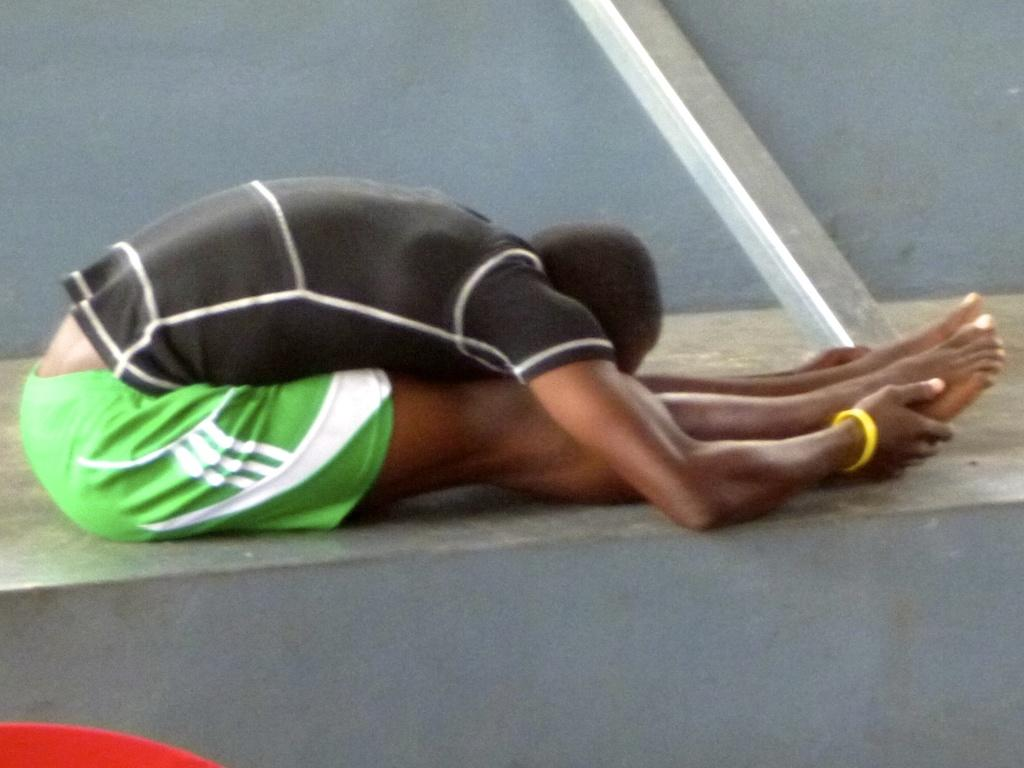What is the person in the image doing? The person is doing something in the image. Where is the person located in the image? The person is sitting on the floor in the image. What is near the person in the image? There is a wall beside the person in the image. How many brothers does the person in the image have? There is no information about the person's brothers in the image, so we cannot determine the number of brothers they have. 